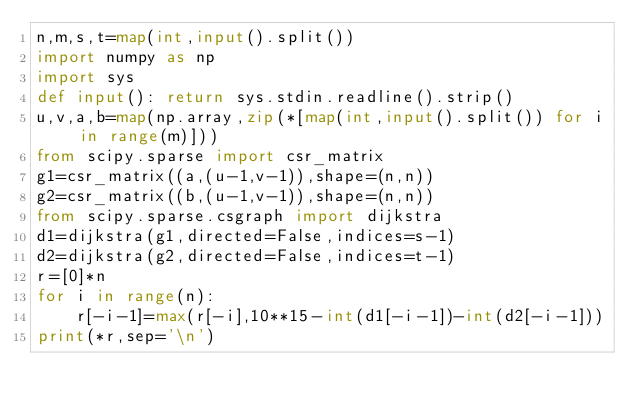<code> <loc_0><loc_0><loc_500><loc_500><_Python_>n,m,s,t=map(int,input().split())
import numpy as np
import sys
def input(): return sys.stdin.readline().strip()
u,v,a,b=map(np.array,zip(*[map(int,input().split()) for i in range(m)]))
from scipy.sparse import csr_matrix
g1=csr_matrix((a,(u-1,v-1)),shape=(n,n))
g2=csr_matrix((b,(u-1,v-1)),shape=(n,n))
from scipy.sparse.csgraph import dijkstra
d1=dijkstra(g1,directed=False,indices=s-1)
d2=dijkstra(g2,directed=False,indices=t-1)
r=[0]*n
for i in range(n):
    r[-i-1]=max(r[-i],10**15-int(d1[-i-1])-int(d2[-i-1]))
print(*r,sep='\n')</code> 